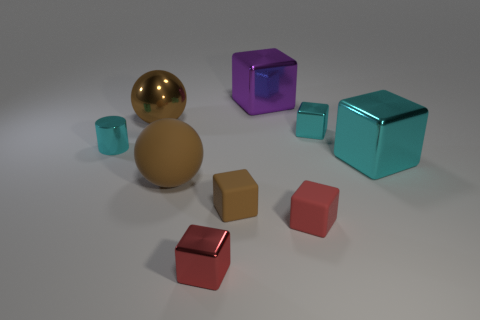How many tiny things are either brown objects or cyan objects?
Offer a very short reply. 3. There is a tiny cyan thing that is in front of the cyan shiny cube that is behind the small cyan cylinder; are there any tiny red metal things behind it?
Give a very brief answer. No. Is there a cube of the same size as the red metal object?
Provide a short and direct response. Yes. What material is the cube that is the same size as the purple object?
Offer a terse response. Metal. Does the purple shiny thing have the same size as the cyan object that is behind the cylinder?
Your answer should be very brief. No. What number of metal objects are either large purple cubes or gray things?
Your answer should be very brief. 1. What number of purple metallic objects have the same shape as the large cyan object?
Ensure brevity in your answer.  1. What material is the tiny cube that is the same color as the metallic cylinder?
Ensure brevity in your answer.  Metal. Is the size of the matte block that is on the left side of the red matte block the same as the thing in front of the red rubber block?
Ensure brevity in your answer.  Yes. There is a big brown metallic thing on the left side of the small red shiny thing; what is its shape?
Give a very brief answer. Sphere. 